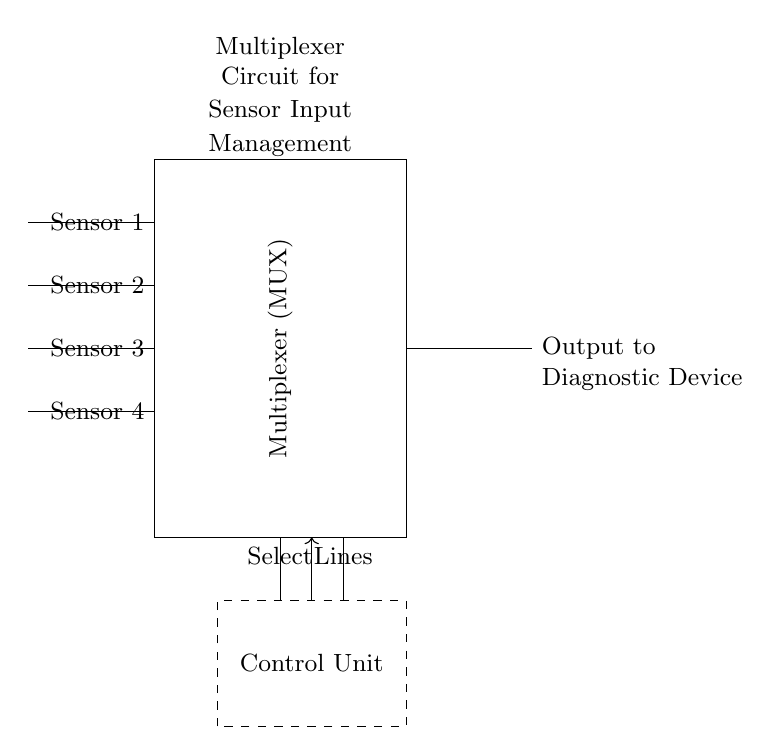What components are present in this circuit? The circuit diagram includes a multiplexer, multiple sensor inputs (4), select lines, an output terminal, and a control unit.
Answer: Multiplexer, sensors, select lines, output, control unit How many sensor inputs are connected to the multiplexer? Counting the lines connected to the multiplexer in the diagram, there are four sensors labeled from Sensor 1 to Sensor 4.
Answer: Four What is the function of the control unit? The control unit is responsible for managing the select lines which determine which sensor's output is sent to the output terminal.
Answer: Managing select lines Which component represents the output in this circuit? The right side of the circuit diagram has an arrow pointing to "Output to Diagnostic Device," indicating the output to be used by the diagnostic device.
Answer: Output to Diagnostic Device What is the purpose of the select lines in a multiplexer? The select lines are used to choose which input (sensor) to connect to the output, effectively allowing the multiplexer to manage multiple inputs.
Answer: Choosing input If Sensor 2 is selected, which sensor output is sent to the diagnostic device? Since Sensor 2 is the second input, if it is selected, its output will be routed to the output terminal which goes to the diagnostic device.
Answer: Sensor 2 output What is the key advantage of using a multiplexer in diagnostic devices? A multiplexer allows the consolidation of multiple sensor outputs into a single line, optimizing the sourcing of data without needing multiple lines.
Answer: Data consolidation 